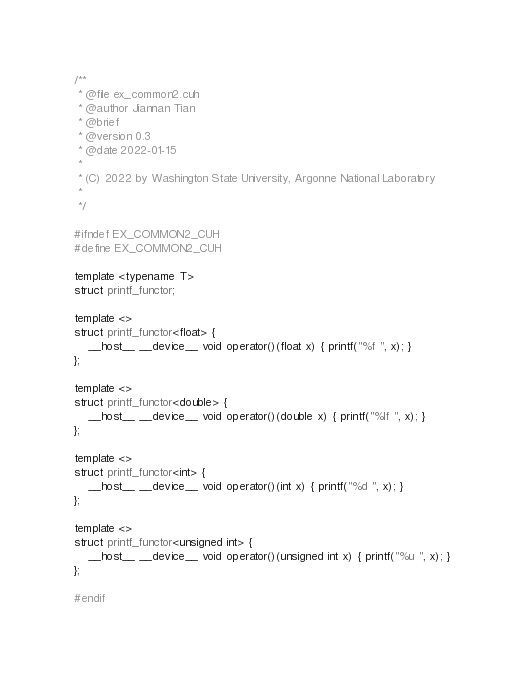<code> <loc_0><loc_0><loc_500><loc_500><_Cuda_>/**
 * @file ex_common2.cuh
 * @author Jiannan Tian
 * @brief
 * @version 0.3
 * @date 2022-01-15
 *
 * (C) 2022 by Washington State University, Argonne National Laboratory
 *
 */

#ifndef EX_COMMON2_CUH
#define EX_COMMON2_CUH

template <typename T>
struct printf_functor;

template <>
struct printf_functor<float> {
    __host__ __device__ void operator()(float x) { printf("%f ", x); }
};

template <>
struct printf_functor<double> {
    __host__ __device__ void operator()(double x) { printf("%lf ", x); }
};

template <>
struct printf_functor<int> {
    __host__ __device__ void operator()(int x) { printf("%d ", x); }
};

template <>
struct printf_functor<unsigned int> {
    __host__ __device__ void operator()(unsigned int x) { printf("%u ", x); }
};

#endif</code> 